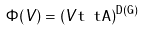<formula> <loc_0><loc_0><loc_500><loc_500>\Phi ( V ) = ( V \tt t \ t A ) ^ { D ( G ) }</formula> 